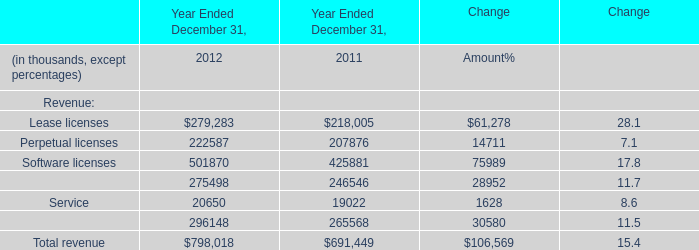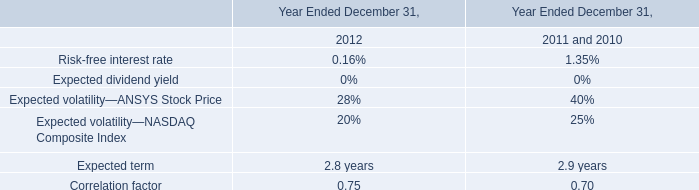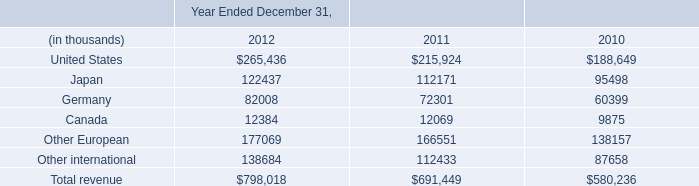what is the total amount incurred , in millions , from lease rental expenses related to the company's executive offices from 2010-2012? 
Computations: (1.3 * 3)
Answer: 3.9. 